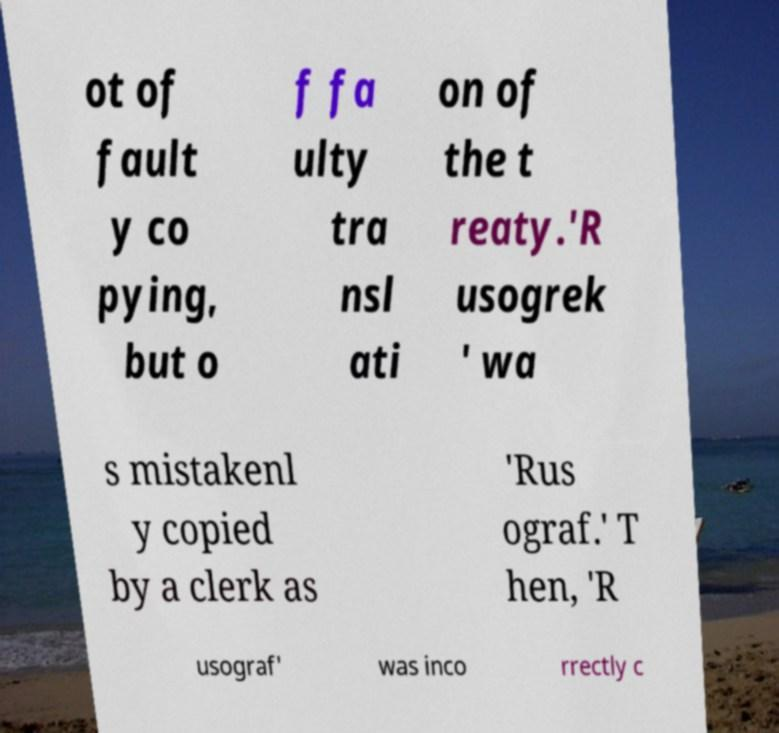What messages or text are displayed in this image? I need them in a readable, typed format. ot of fault y co pying, but o f fa ulty tra nsl ati on of the t reaty.'R usogrek ' wa s mistakenl y copied by a clerk as 'Rus ograf.' T hen, 'R usograf' was inco rrectly c 